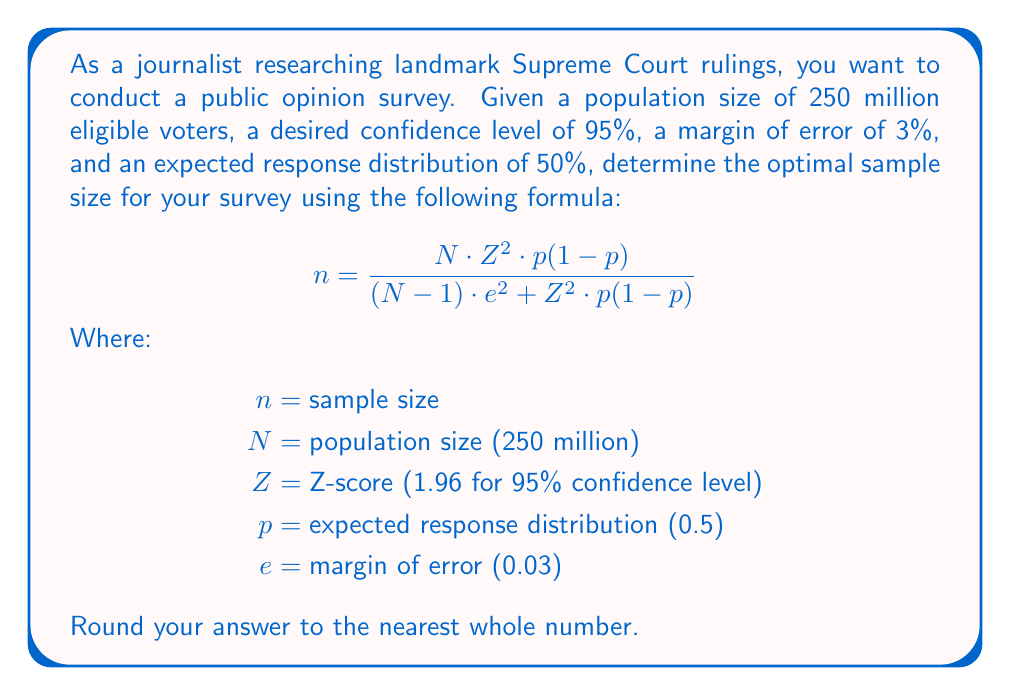Solve this math problem. To solve this problem, we'll follow these steps:

1. Identify the given values:
   $N = 250,000,000$
   $Z = 1.96$ (for 95% confidence level)
   $p = 0.5$ (50% response distribution)
   $e = 0.03$ (3% margin of error)

2. Substitute these values into the formula:

   $$ n = \frac{250,000,000 \cdot 1.96^2 \cdot 0.5(1-0.5)}{(250,000,000-1) \cdot 0.03^2 + 1.96^2 \cdot 0.5(1-0.5)} $$

3. Calculate the numerator:
   $250,000,000 \cdot 1.96^2 \cdot 0.5(1-0.5) = 240,100,000$

4. Calculate the denominator:
   $(250,000,000-1) \cdot 0.03^2 + 1.96^2 \cdot 0.5(1-0.5) = 224,999.9604 + 0.9604 = 225,000.9208$

5. Divide the numerator by the denominator:
   $$ n = \frac{240,100,000}{225,000.9208} = 1,067.1067... $$

6. Round the result to the nearest whole number:
   $n \approx 1,067$

Therefore, the optimal sample size for the public opinion survey on landmark Supreme Court rulings is 1,067 respondents.
Answer: 1,067 respondents 